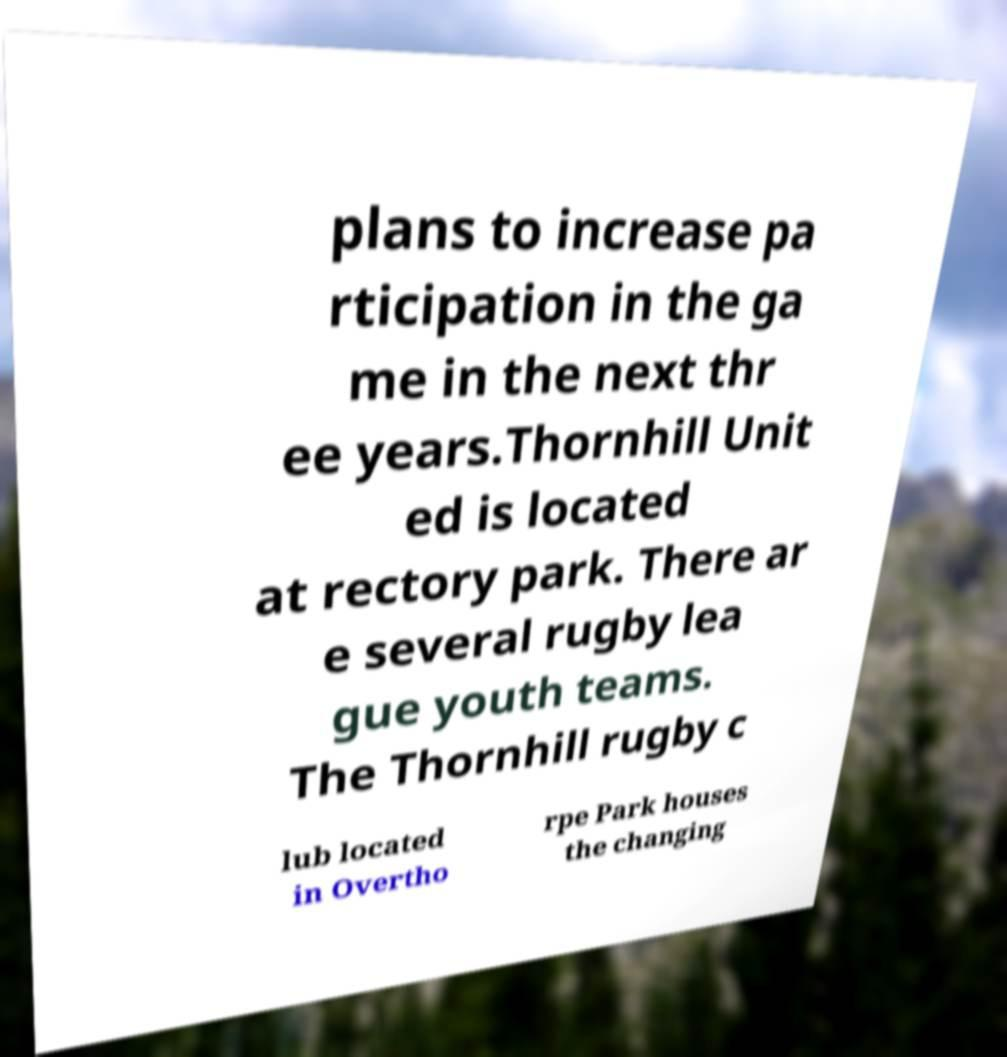Please read and relay the text visible in this image. What does it say? plans to increase pa rticipation in the ga me in the next thr ee years.Thornhill Unit ed is located at rectory park. There ar e several rugby lea gue youth teams. The Thornhill rugby c lub located in Overtho rpe Park houses the changing 